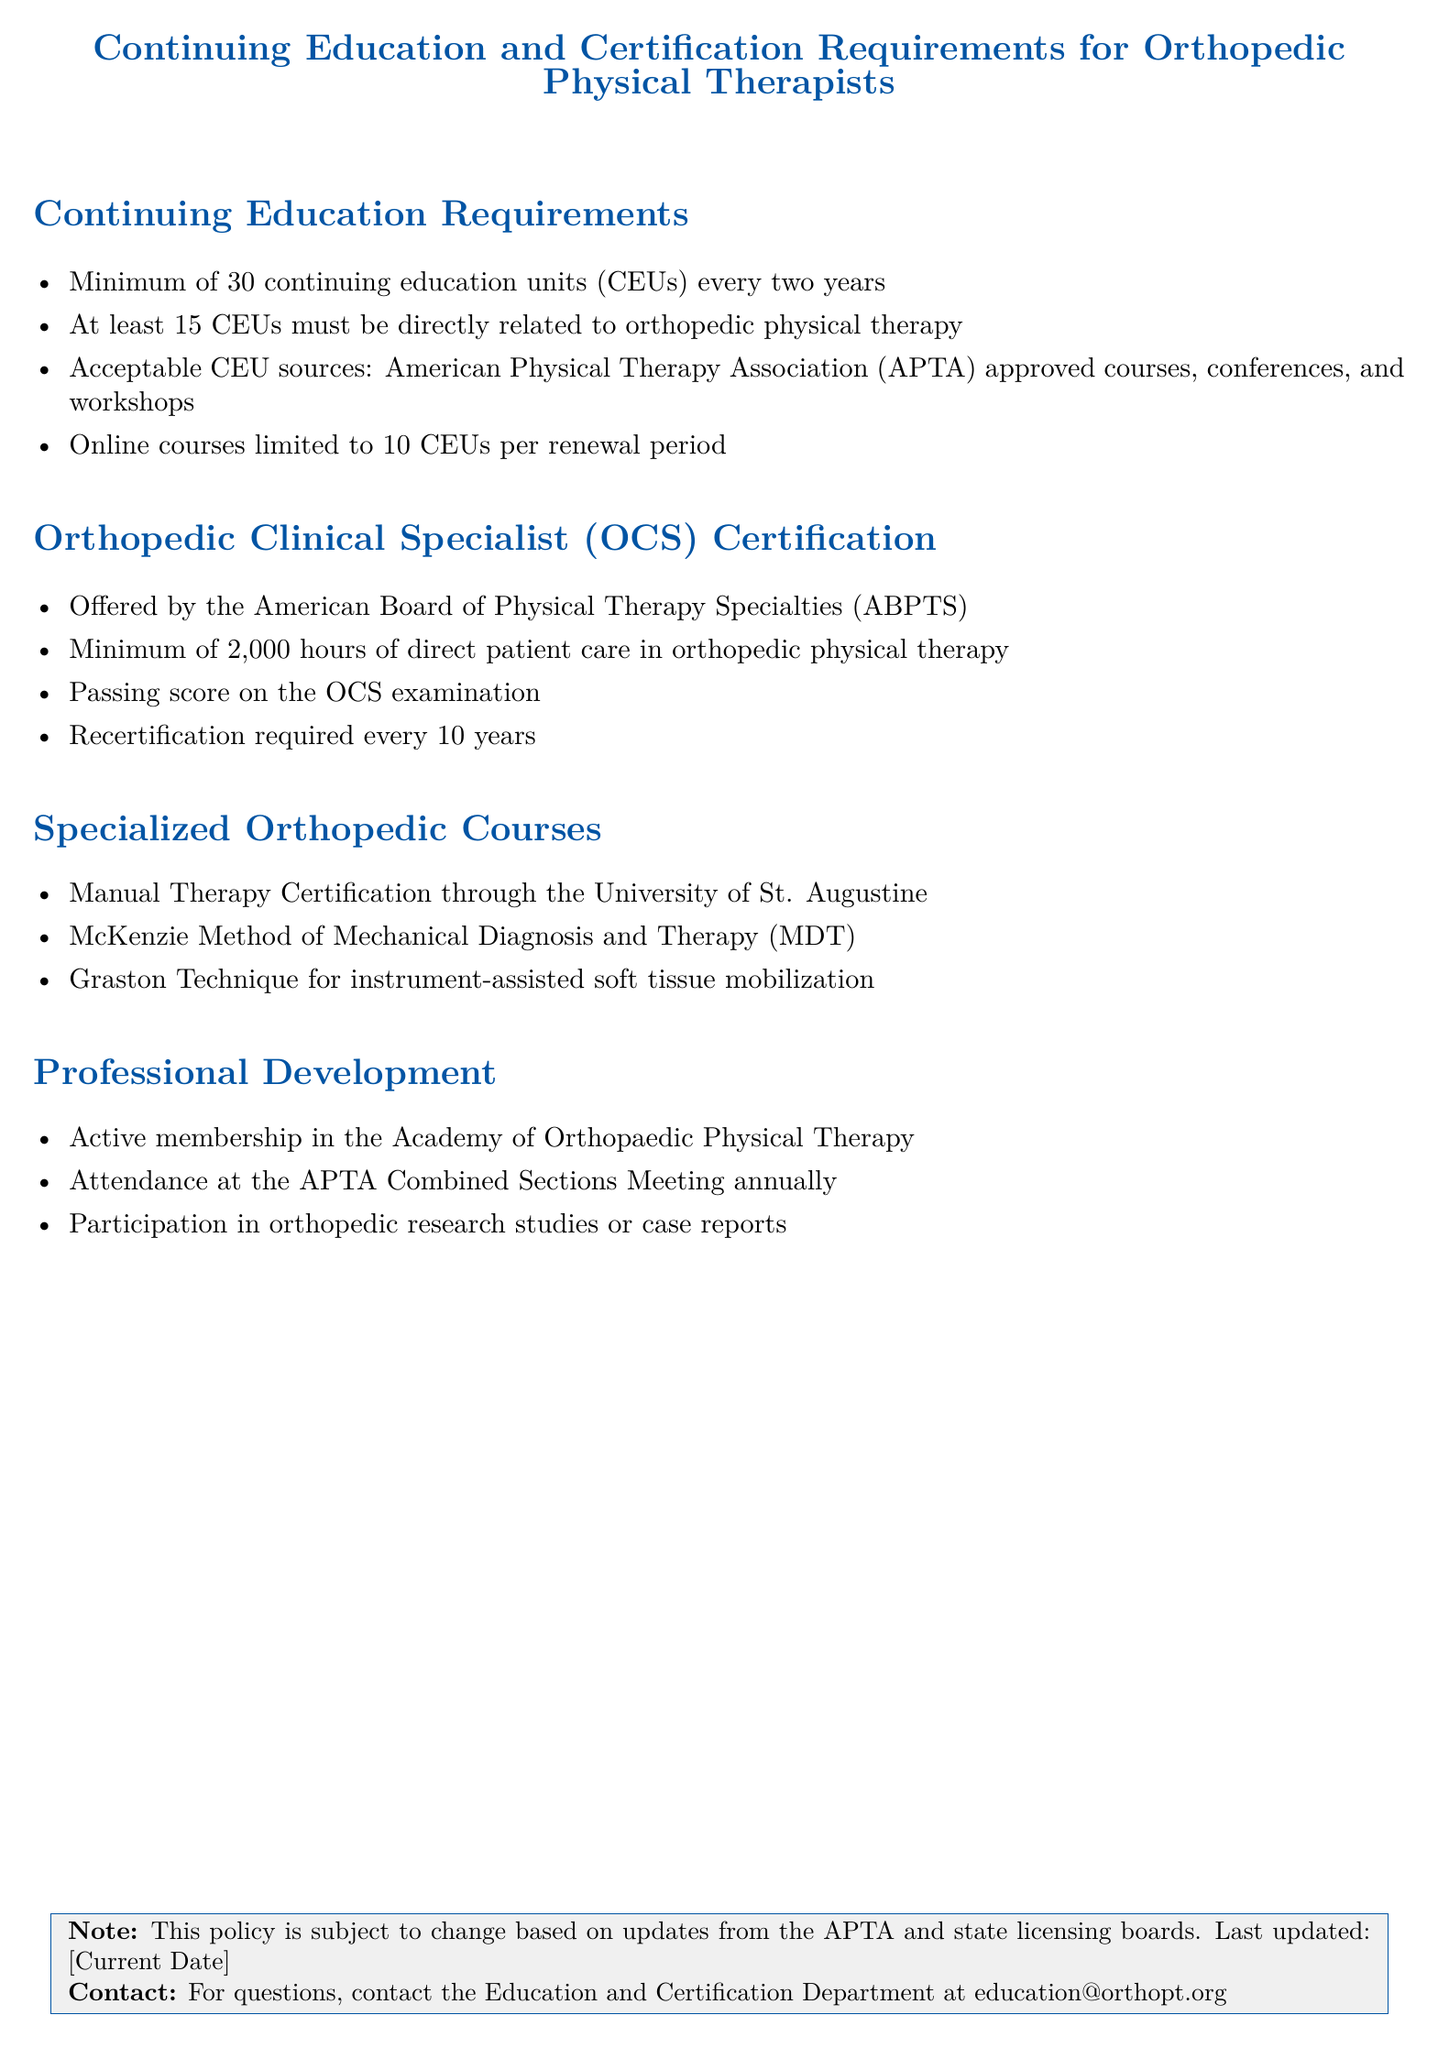What is the minimum number of CEUs required every two years? The document states that a minimum of 30 continuing education units (CEUs) are required every two years.
Answer: 30 CEUs How many CEUs must be orthopedic related? It is specified that at least 15 CEUs must be directly related to orthopedic physical therapy.
Answer: 15 CEUs What organization offers the OCS certification? The document mentions that the OCS certification is offered by the American Board of Physical Therapy Specialties (ABPTS).
Answer: American Board of Physical Therapy Specialties How many hours of direct patient care are needed for OCS certification? The document outlines that a minimum of 2,000 hours of direct patient care in orthopedic physical therapy is necessary.
Answer: 2,000 hours How often is recertification required for OCS? According to the document, recertification for the OCS is required every 10 years.
Answer: 10 years What is one of the specialized orthopedic courses listed? The document lists several specialized orthopedic courses, such as Manual Therapy Certification through the University of St. Augustine.
Answer: Manual Therapy Certification What must a physical therapist actively maintain as part of professional development? It specifies that active membership in the Academy of Orthopaedic Physical Therapy is required for professional development.
Answer: Active membership What is the APTA Combined Sections Meeting? The document indicates that attendance at the APTA Combined Sections Meeting is part of professional development.
Answer: APTA Combined Sections Meeting 